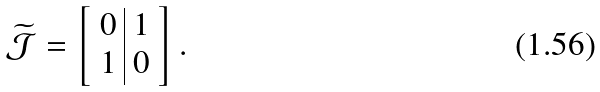<formula> <loc_0><loc_0><loc_500><loc_500>\widetilde { \mathcal { J } } = \left [ \begin{array} { c | c } 0 & 1 \\ 1 & 0 \end{array} \right ] .</formula> 